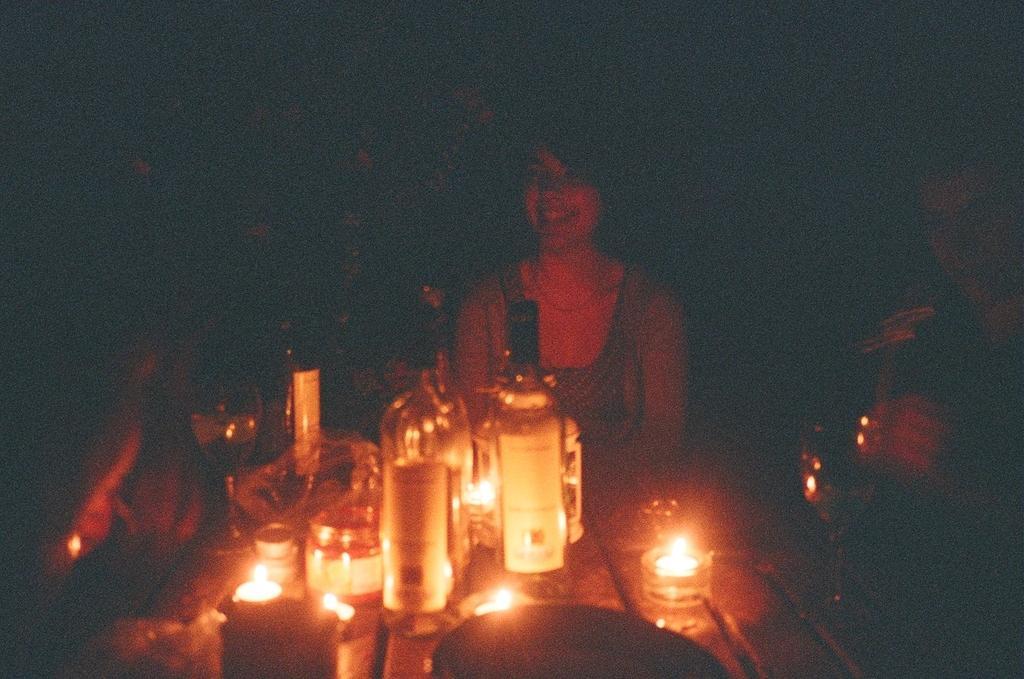In one or two sentences, can you explain what this image depicts? In this image I can see the bottles on the table. I can see some people. I can also see the image is blurred. 